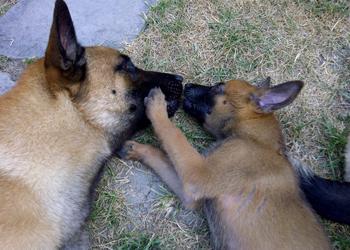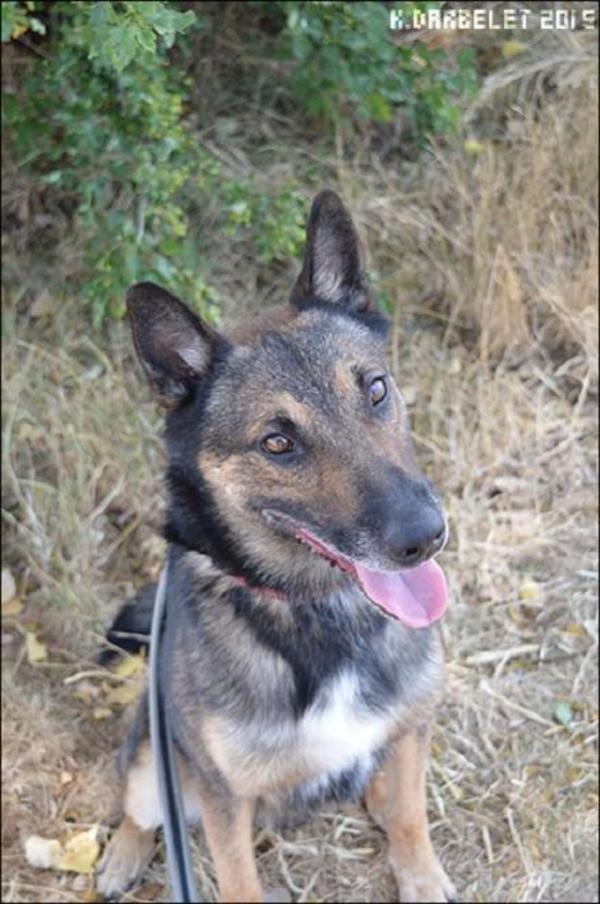The first image is the image on the left, the second image is the image on the right. Evaluate the accuracy of this statement regarding the images: "There are 2 dogs standing.". Is it true? Answer yes or no. No. The first image is the image on the left, the second image is the image on the right. Given the left and right images, does the statement "There are two dogs standing in the grass." hold true? Answer yes or no. No. 